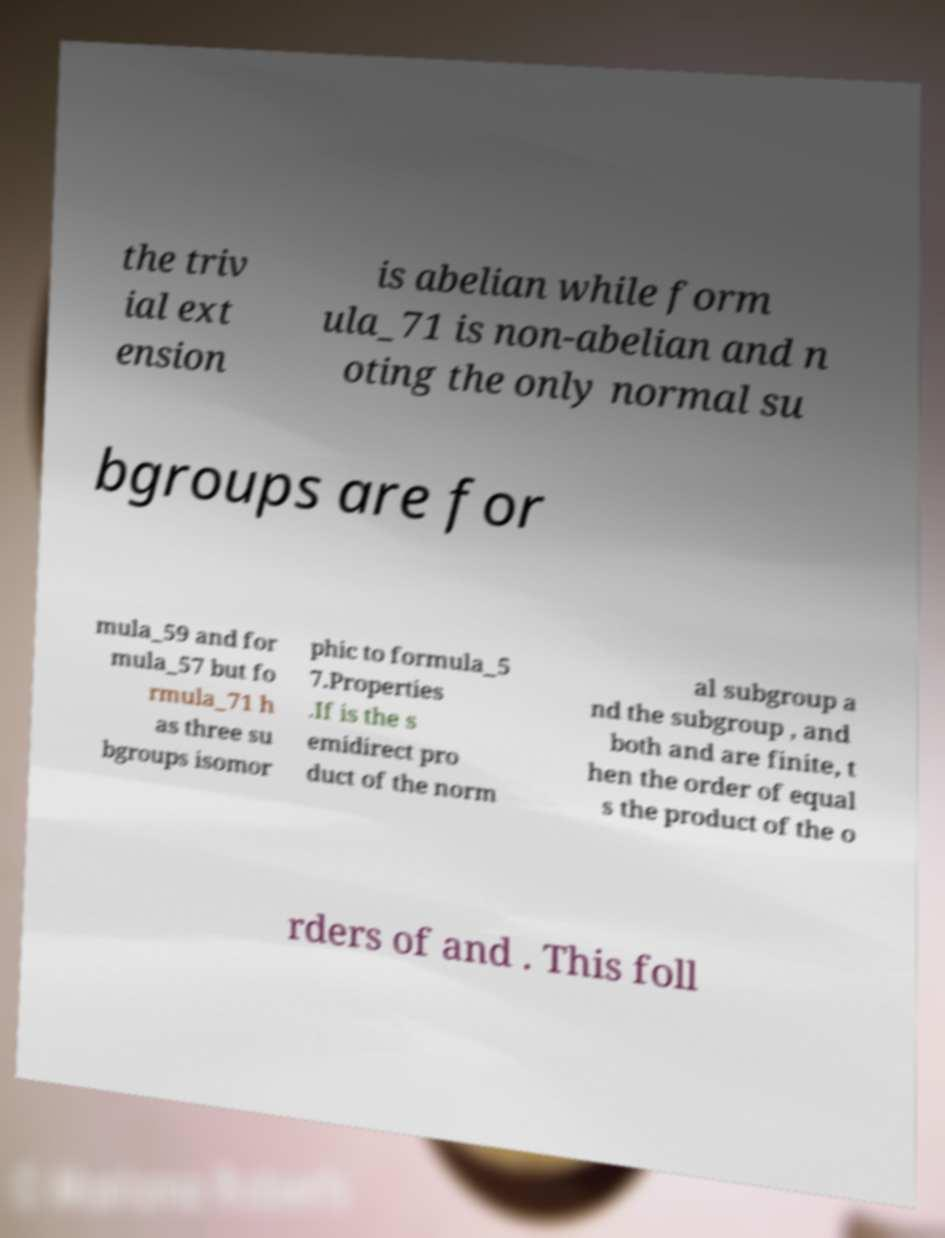Please identify and transcribe the text found in this image. the triv ial ext ension is abelian while form ula_71 is non-abelian and n oting the only normal su bgroups are for mula_59 and for mula_57 but fo rmula_71 h as three su bgroups isomor phic to formula_5 7.Properties .If is the s emidirect pro duct of the norm al subgroup a nd the subgroup , and both and are finite, t hen the order of equal s the product of the o rders of and . This foll 